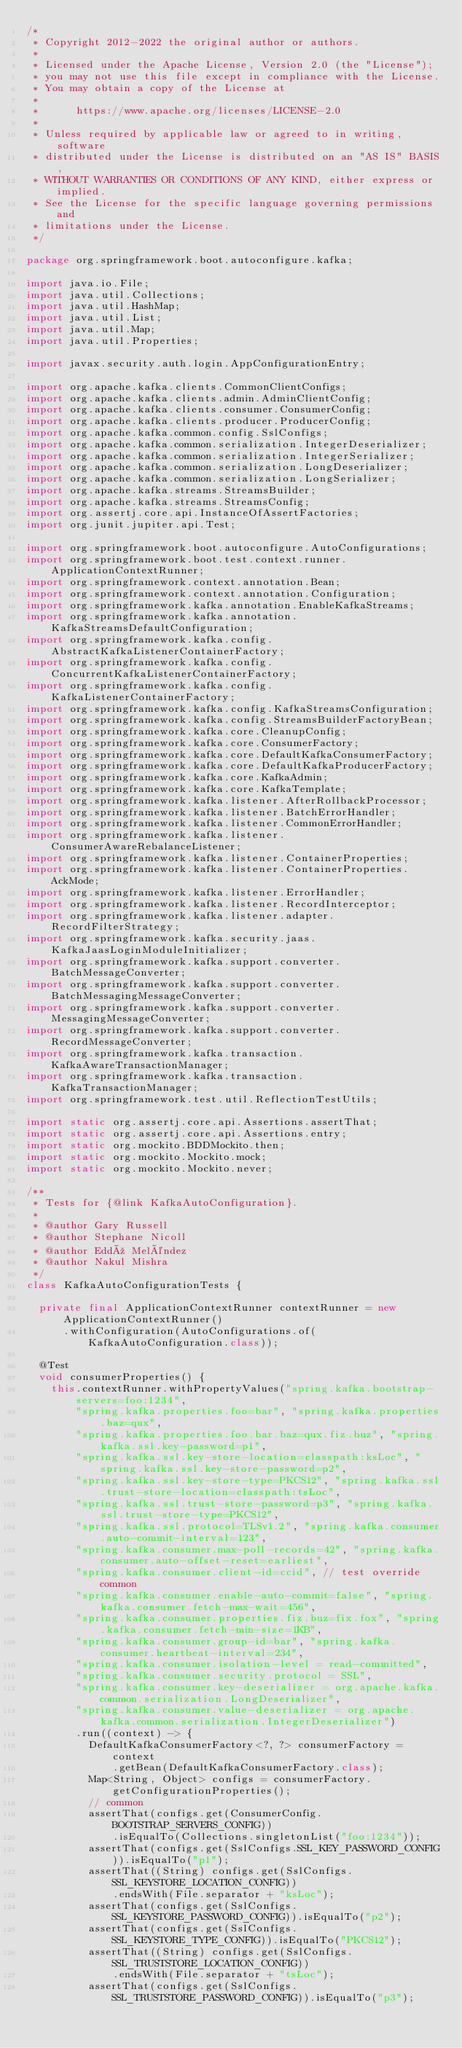Convert code to text. <code><loc_0><loc_0><loc_500><loc_500><_Java_>/*
 * Copyright 2012-2022 the original author or authors.
 *
 * Licensed under the Apache License, Version 2.0 (the "License");
 * you may not use this file except in compliance with the License.
 * You may obtain a copy of the License at
 *
 *      https://www.apache.org/licenses/LICENSE-2.0
 *
 * Unless required by applicable law or agreed to in writing, software
 * distributed under the License is distributed on an "AS IS" BASIS,
 * WITHOUT WARRANTIES OR CONDITIONS OF ANY KIND, either express or implied.
 * See the License for the specific language governing permissions and
 * limitations under the License.
 */

package org.springframework.boot.autoconfigure.kafka;

import java.io.File;
import java.util.Collections;
import java.util.HashMap;
import java.util.List;
import java.util.Map;
import java.util.Properties;

import javax.security.auth.login.AppConfigurationEntry;

import org.apache.kafka.clients.CommonClientConfigs;
import org.apache.kafka.clients.admin.AdminClientConfig;
import org.apache.kafka.clients.consumer.ConsumerConfig;
import org.apache.kafka.clients.producer.ProducerConfig;
import org.apache.kafka.common.config.SslConfigs;
import org.apache.kafka.common.serialization.IntegerDeserializer;
import org.apache.kafka.common.serialization.IntegerSerializer;
import org.apache.kafka.common.serialization.LongDeserializer;
import org.apache.kafka.common.serialization.LongSerializer;
import org.apache.kafka.streams.StreamsBuilder;
import org.apache.kafka.streams.StreamsConfig;
import org.assertj.core.api.InstanceOfAssertFactories;
import org.junit.jupiter.api.Test;

import org.springframework.boot.autoconfigure.AutoConfigurations;
import org.springframework.boot.test.context.runner.ApplicationContextRunner;
import org.springframework.context.annotation.Bean;
import org.springframework.context.annotation.Configuration;
import org.springframework.kafka.annotation.EnableKafkaStreams;
import org.springframework.kafka.annotation.KafkaStreamsDefaultConfiguration;
import org.springframework.kafka.config.AbstractKafkaListenerContainerFactory;
import org.springframework.kafka.config.ConcurrentKafkaListenerContainerFactory;
import org.springframework.kafka.config.KafkaListenerContainerFactory;
import org.springframework.kafka.config.KafkaStreamsConfiguration;
import org.springframework.kafka.config.StreamsBuilderFactoryBean;
import org.springframework.kafka.core.CleanupConfig;
import org.springframework.kafka.core.ConsumerFactory;
import org.springframework.kafka.core.DefaultKafkaConsumerFactory;
import org.springframework.kafka.core.DefaultKafkaProducerFactory;
import org.springframework.kafka.core.KafkaAdmin;
import org.springframework.kafka.core.KafkaTemplate;
import org.springframework.kafka.listener.AfterRollbackProcessor;
import org.springframework.kafka.listener.BatchErrorHandler;
import org.springframework.kafka.listener.CommonErrorHandler;
import org.springframework.kafka.listener.ConsumerAwareRebalanceListener;
import org.springframework.kafka.listener.ContainerProperties;
import org.springframework.kafka.listener.ContainerProperties.AckMode;
import org.springframework.kafka.listener.ErrorHandler;
import org.springframework.kafka.listener.RecordInterceptor;
import org.springframework.kafka.listener.adapter.RecordFilterStrategy;
import org.springframework.kafka.security.jaas.KafkaJaasLoginModuleInitializer;
import org.springframework.kafka.support.converter.BatchMessageConverter;
import org.springframework.kafka.support.converter.BatchMessagingMessageConverter;
import org.springframework.kafka.support.converter.MessagingMessageConverter;
import org.springframework.kafka.support.converter.RecordMessageConverter;
import org.springframework.kafka.transaction.KafkaAwareTransactionManager;
import org.springframework.kafka.transaction.KafkaTransactionManager;
import org.springframework.test.util.ReflectionTestUtils;

import static org.assertj.core.api.Assertions.assertThat;
import static org.assertj.core.api.Assertions.entry;
import static org.mockito.BDDMockito.then;
import static org.mockito.Mockito.mock;
import static org.mockito.Mockito.never;

/**
 * Tests for {@link KafkaAutoConfiguration}.
 *
 * @author Gary Russell
 * @author Stephane Nicoll
 * @author Eddú Meléndez
 * @author Nakul Mishra
 */
class KafkaAutoConfigurationTests {

	private final ApplicationContextRunner contextRunner = new ApplicationContextRunner()
			.withConfiguration(AutoConfigurations.of(KafkaAutoConfiguration.class));

	@Test
	void consumerProperties() {
		this.contextRunner.withPropertyValues("spring.kafka.bootstrap-servers=foo:1234",
				"spring.kafka.properties.foo=bar", "spring.kafka.properties.baz=qux",
				"spring.kafka.properties.foo.bar.baz=qux.fiz.buz", "spring.kafka.ssl.key-password=p1",
				"spring.kafka.ssl.key-store-location=classpath:ksLoc", "spring.kafka.ssl.key-store-password=p2",
				"spring.kafka.ssl.key-store-type=PKCS12", "spring.kafka.ssl.trust-store-location=classpath:tsLoc",
				"spring.kafka.ssl.trust-store-password=p3", "spring.kafka.ssl.trust-store-type=PKCS12",
				"spring.kafka.ssl.protocol=TLSv1.2", "spring.kafka.consumer.auto-commit-interval=123",
				"spring.kafka.consumer.max-poll-records=42", "spring.kafka.consumer.auto-offset-reset=earliest",
				"spring.kafka.consumer.client-id=ccid", // test override common
				"spring.kafka.consumer.enable-auto-commit=false", "spring.kafka.consumer.fetch-max-wait=456",
				"spring.kafka.consumer.properties.fiz.buz=fix.fox", "spring.kafka.consumer.fetch-min-size=1KB",
				"spring.kafka.consumer.group-id=bar", "spring.kafka.consumer.heartbeat-interval=234",
				"spring.kafka.consumer.isolation-level = read-committed",
				"spring.kafka.consumer.security.protocol = SSL",
				"spring.kafka.consumer.key-deserializer = org.apache.kafka.common.serialization.LongDeserializer",
				"spring.kafka.consumer.value-deserializer = org.apache.kafka.common.serialization.IntegerDeserializer")
				.run((context) -> {
					DefaultKafkaConsumerFactory<?, ?> consumerFactory = context
							.getBean(DefaultKafkaConsumerFactory.class);
					Map<String, Object> configs = consumerFactory.getConfigurationProperties();
					// common
					assertThat(configs.get(ConsumerConfig.BOOTSTRAP_SERVERS_CONFIG))
							.isEqualTo(Collections.singletonList("foo:1234"));
					assertThat(configs.get(SslConfigs.SSL_KEY_PASSWORD_CONFIG)).isEqualTo("p1");
					assertThat((String) configs.get(SslConfigs.SSL_KEYSTORE_LOCATION_CONFIG))
							.endsWith(File.separator + "ksLoc");
					assertThat(configs.get(SslConfigs.SSL_KEYSTORE_PASSWORD_CONFIG)).isEqualTo("p2");
					assertThat(configs.get(SslConfigs.SSL_KEYSTORE_TYPE_CONFIG)).isEqualTo("PKCS12");
					assertThat((String) configs.get(SslConfigs.SSL_TRUSTSTORE_LOCATION_CONFIG))
							.endsWith(File.separator + "tsLoc");
					assertThat(configs.get(SslConfigs.SSL_TRUSTSTORE_PASSWORD_CONFIG)).isEqualTo("p3");</code> 